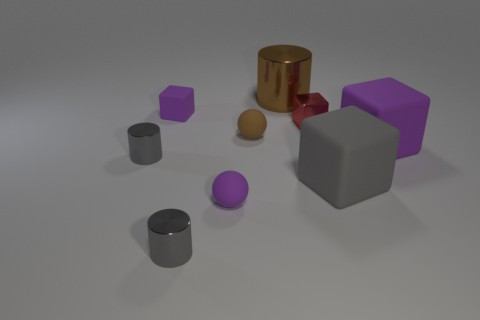Add 1 gray rubber cubes. How many objects exist? 10 Subtract all cyan cubes. Subtract all gray spheres. How many cubes are left? 4 Subtract all cylinders. How many objects are left? 6 Add 4 tiny purple rubber cubes. How many tiny purple rubber cubes are left? 5 Add 7 blue cylinders. How many blue cylinders exist? 7 Subtract 0 blue cubes. How many objects are left? 9 Subtract all purple rubber objects. Subtract all tiny matte blocks. How many objects are left? 5 